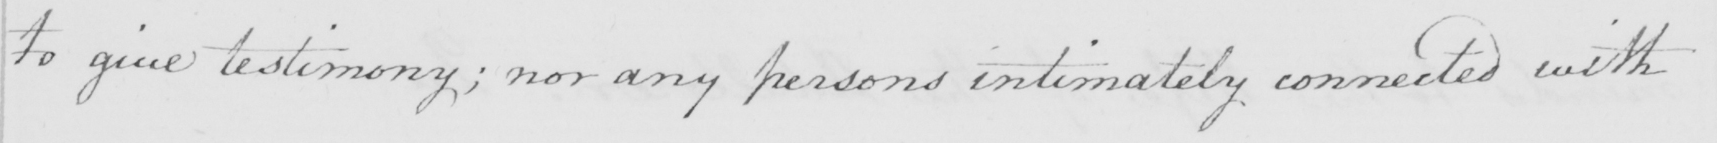Can you read and transcribe this handwriting? to give testimony ; nor any persons intimately connected with 